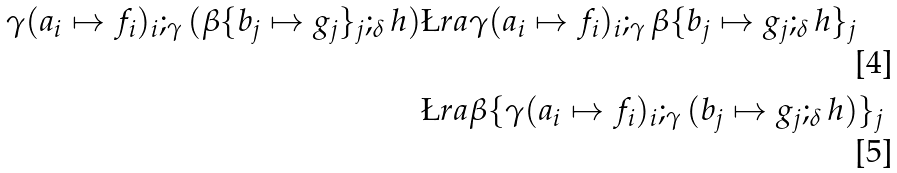Convert formula to latex. <formula><loc_0><loc_0><loc_500><loc_500>\gamma ( a _ { i } \mapsto f _ { i } ) _ { i } ; _ { \gamma } ( \beta \{ b _ { j } \mapsto g _ { j } \} _ { j } ; _ { \delta } h ) & \L r a \gamma ( a _ { i } \mapsto f _ { i } ) _ { i } ; _ { \gamma } \beta \{ b _ { j } \mapsto g _ { j } ; _ { \delta } h \} _ { j } \\ & \L r a \beta \{ \gamma ( a _ { i } \mapsto f _ { i } ) _ { i } ; _ { \gamma } ( b _ { j } \mapsto g _ { j } ; _ { \delta } h ) \} _ { j }</formula> 